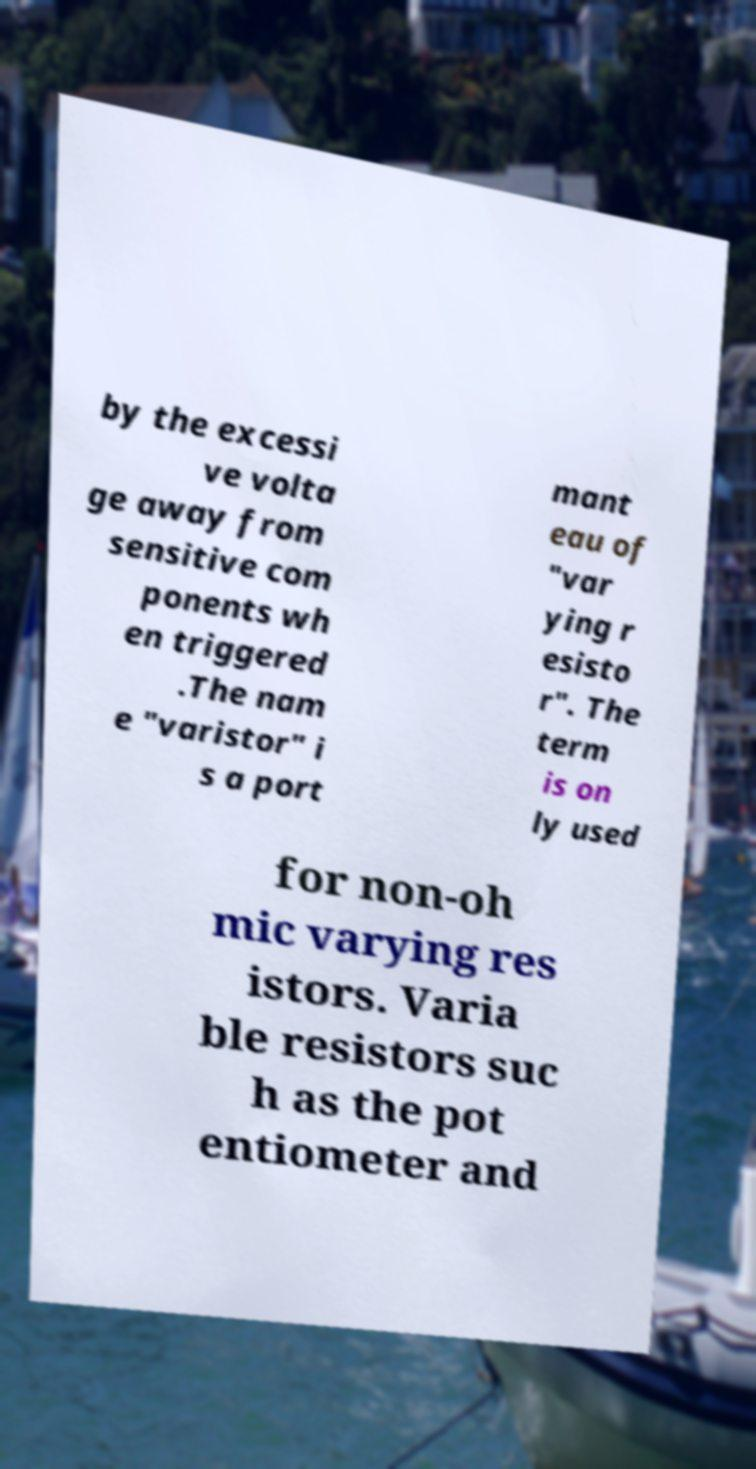I need the written content from this picture converted into text. Can you do that? by the excessi ve volta ge away from sensitive com ponents wh en triggered .The nam e "varistor" i s a port mant eau of "var ying r esisto r". The term is on ly used for non-oh mic varying res istors. Varia ble resistors suc h as the pot entiometer and 